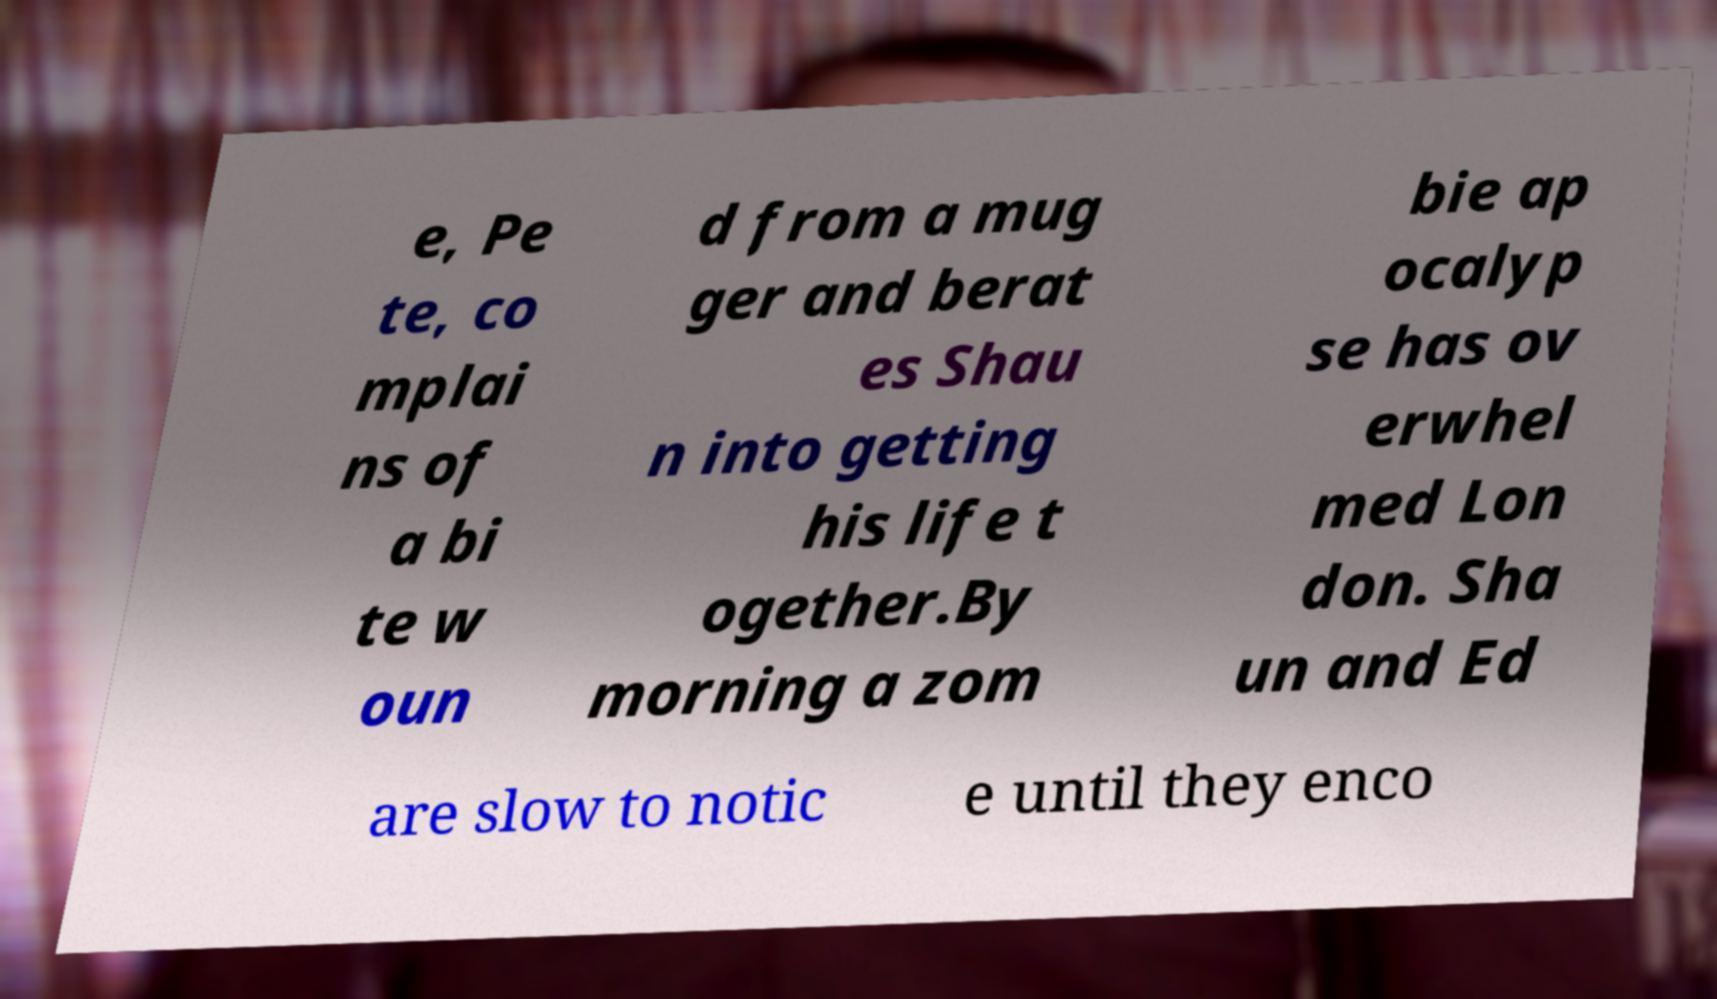For documentation purposes, I need the text within this image transcribed. Could you provide that? e, Pe te, co mplai ns of a bi te w oun d from a mug ger and berat es Shau n into getting his life t ogether.By morning a zom bie ap ocalyp se has ov erwhel med Lon don. Sha un and Ed are slow to notic e until they enco 